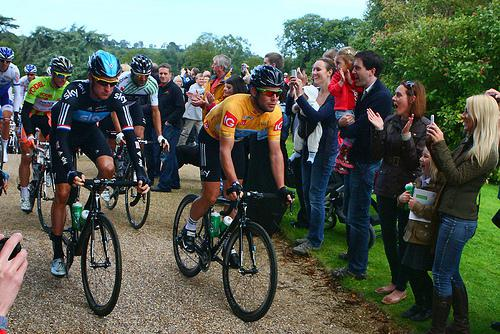Question: who are the people cheering for?
Choices:
A. The cyclists.
B. Lance Armstrong.
C. The Bodeans.
D. Jackson Brown.
Answer with the letter. Answer: A Question: what are the cyclists wearing on their faces?
Choices:
A. Sunscreen.
B. Sun glasses.
C. Lipgloss.
D. Nose rings.
Answer with the letter. Answer: B Question: what are attached to the bicycles?
Choices:
A. Water bottles.
B. Speedometers.
C. Bags.
D. Air pumps.
Answer with the letter. Answer: A 